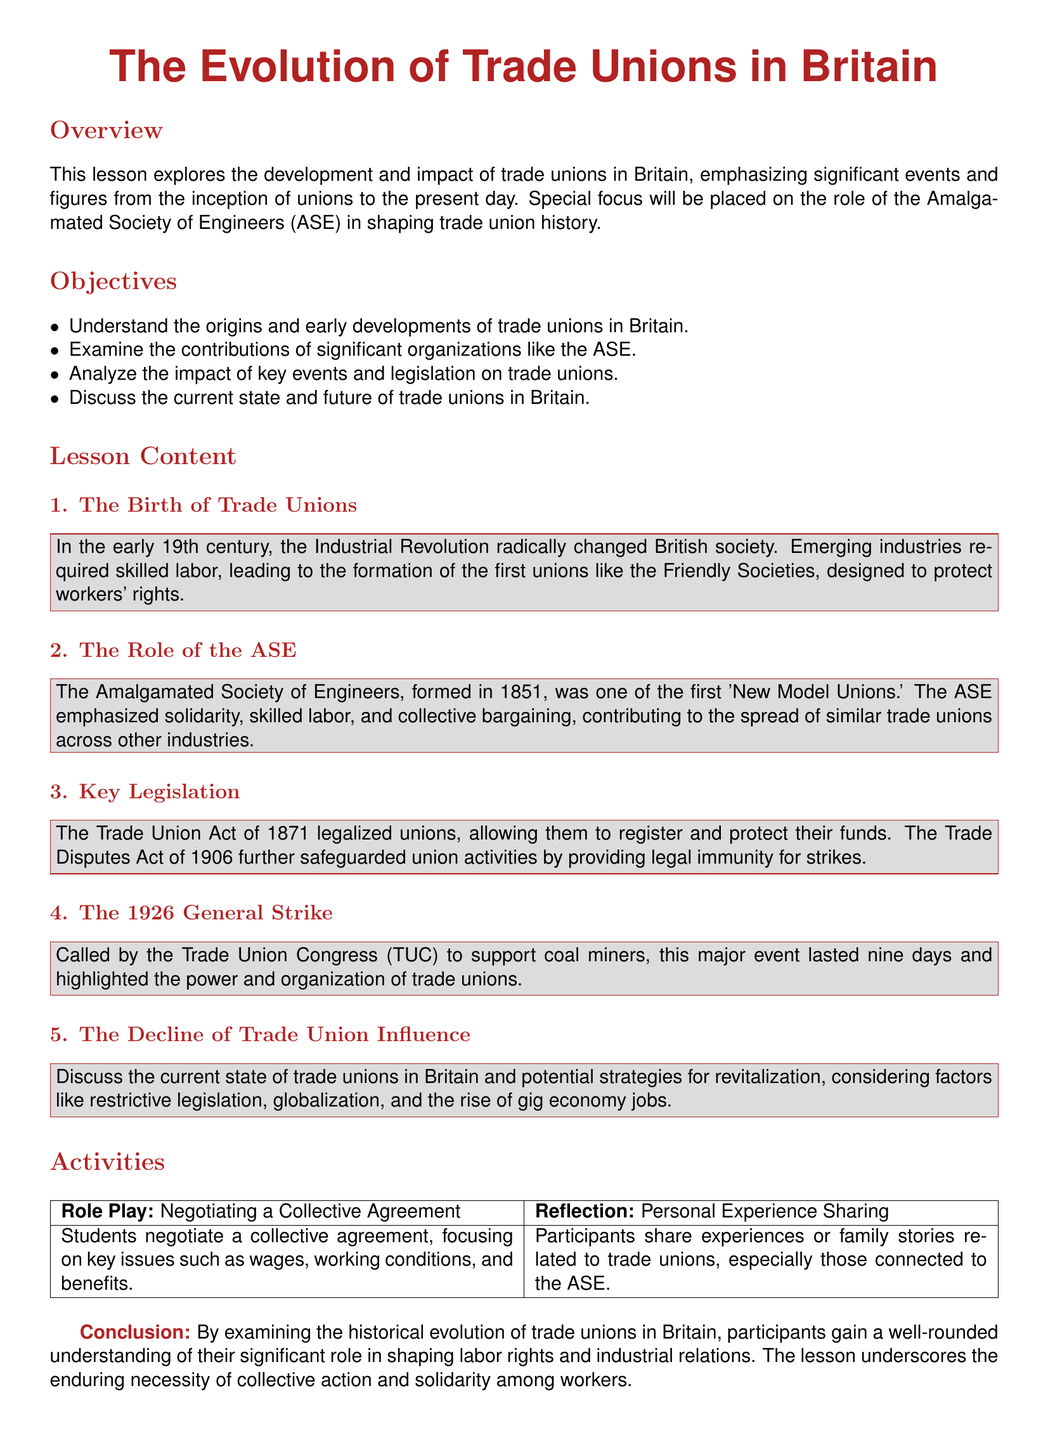What is the main focus of the lesson? The lesson focuses on the development and impact of trade unions in Britain.
Answer: development and impact of trade unions in Britain When was the Amalgamated Society of Engineers formed? The document states that the ASE was formed in 1851.
Answer: 1851 What legislation legalized trade unions in Britain? The Trade Union Act of 1871 is mentioned as legalizing unions.
Answer: Trade Union Act of 1871 What event lasted nine days and was called by the Trade Union Congress? The document refers to the 1926 General Strike as lasting nine days.
Answer: 1926 General Strike Which act provided legal immunity for strikes? The Trade Disputes Act of 1906 is highlighted as providing legal immunity.
Answer: Trade Disputes Act of 1906 What strategy is discussed for revitalizing trade unions? The document suggests considering factors like restrictive legislation and globalization.
Answer: restrictive legislation and globalization What does the lesson conclude about the necessity of collective action? The conclusion emphasizes the enduring necessity of collective action and solidarity.
Answer: enduring necessity of collective action and solidarity 